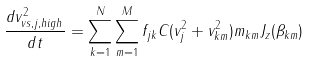Convert formula to latex. <formula><loc_0><loc_0><loc_500><loc_500>\frac { d v _ { v s , j , h i g h } ^ { 2 } } { d t } = \sum _ { k = 1 } ^ { N } \sum _ { m = 1 } ^ { M } f _ { j k } C ( v _ { j } ^ { 2 } + v _ { k m } ^ { 2 } ) m _ { k m } J _ { z } ( \beta _ { k m } )</formula> 